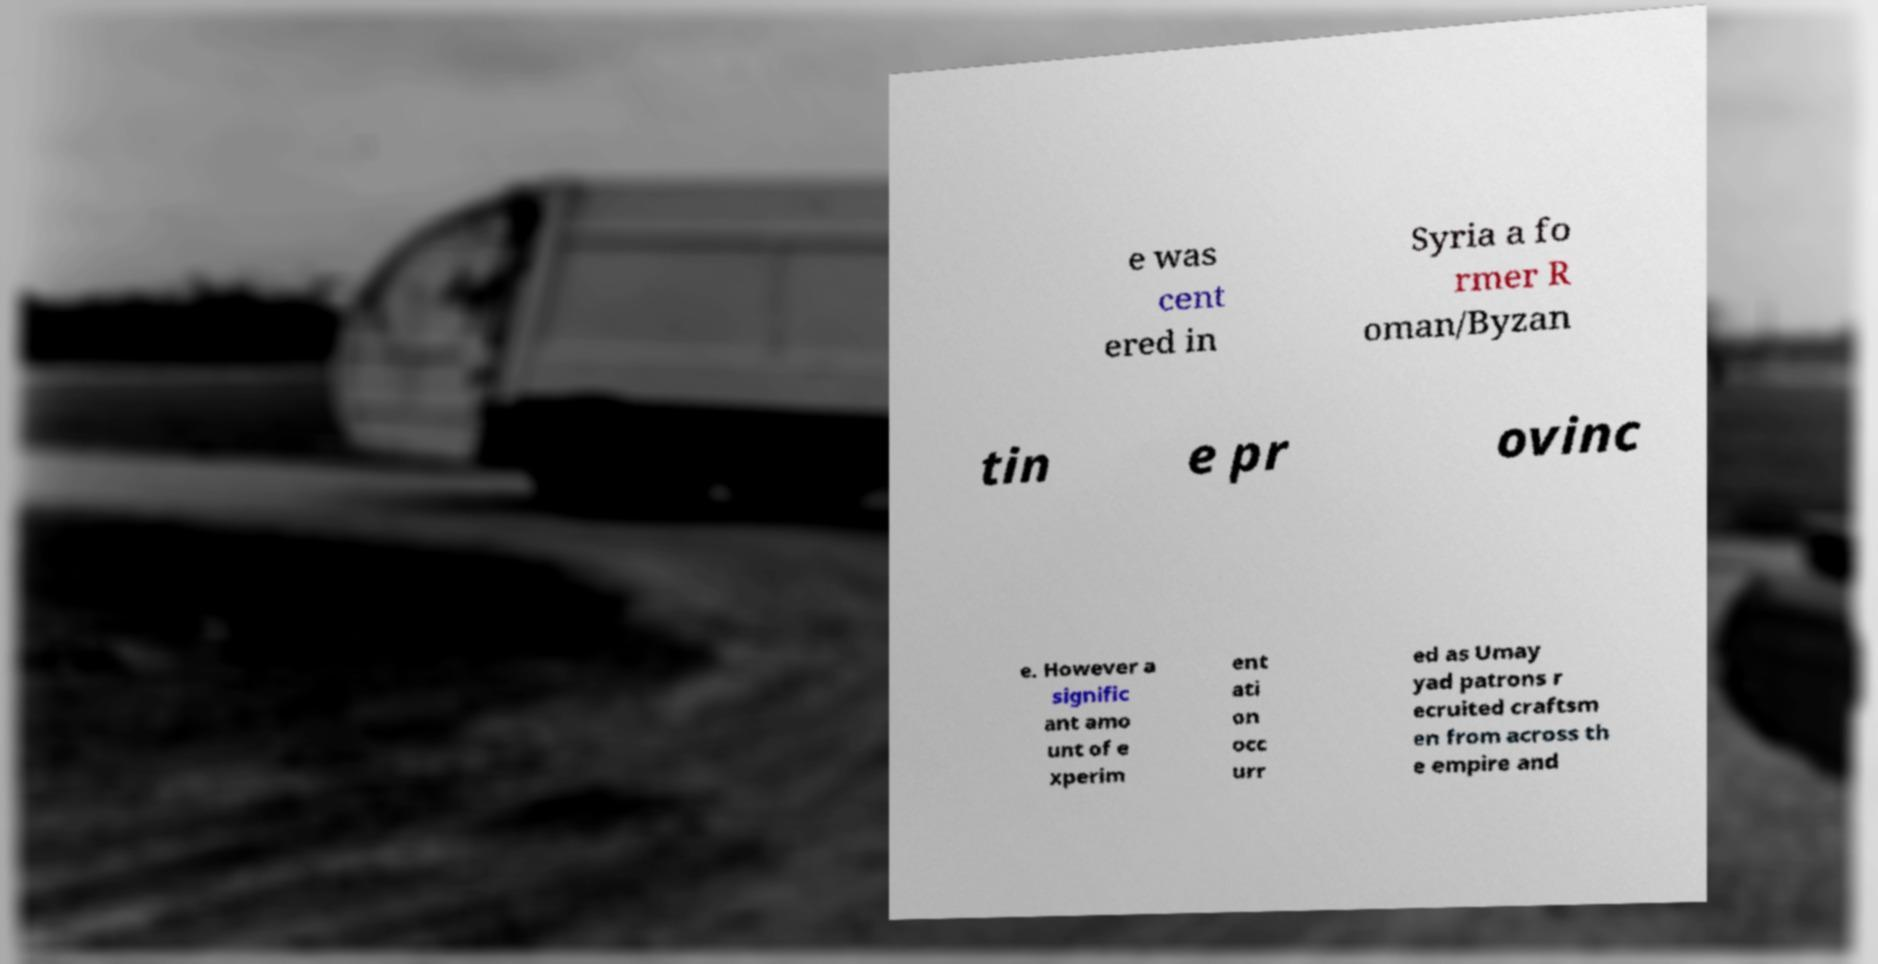Please read and relay the text visible in this image. What does it say? e was cent ered in Syria a fo rmer R oman/Byzan tin e pr ovinc e. However a signific ant amo unt of e xperim ent ati on occ urr ed as Umay yad patrons r ecruited craftsm en from across th e empire and 